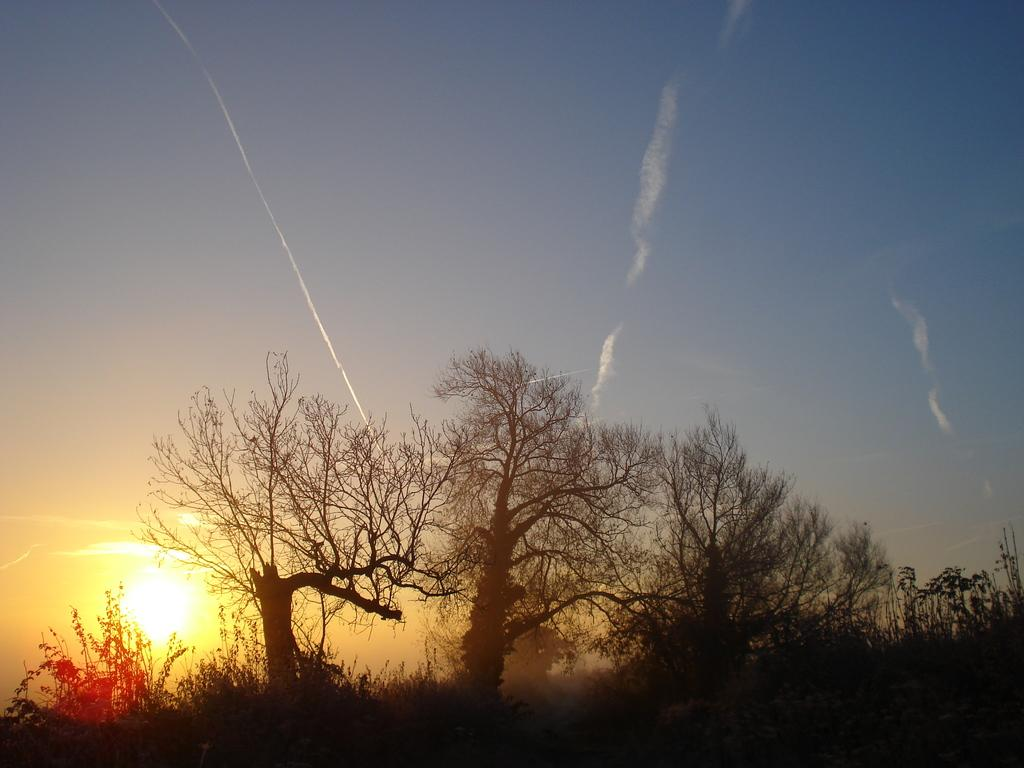What type of vegetation is present in the image? There are trees and plants in the image. What can be seen in the background of the image? There is a sunset visible in the background of the image. What part of the natural environment is visible in the image? The sky is visible in the background of the image. What type of meat is being served with the fork in the image? There is no fork or meat present in the image. What wish can be granted by looking at the image? There is no wish-granting element present in the image. 